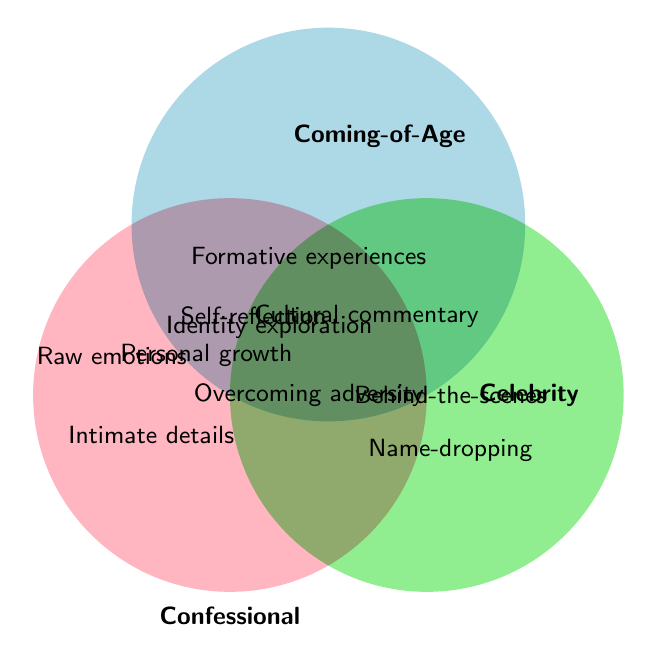What writing styles are unique to the Confessional genre? The Confessional circle does not overlap with other genres for these styles, which appear as standalone elements in the figure.
Answer: Raw emotions, Intimate details What are the shared writing styles between Confessional and Coming-of-Age genres? Identify the overlapping section between the Confessional and Coming-of-Age circles that do not include the Celebrity genre.
Answer: Self-reflection, Personal growth Which style is shared among all three genres? Look in the central overlapping area where Confessional, Coming-of-Age, and Celebrity intersect.
Answer: Overcoming adversity What styles are associated only with the Coming-of-Age genre? These styles are located solely within the Coming-of-Age circle but outside of any overlap with the other circles.
Answer: Formative experiences, Identity exploration Name a writing style that is shared between Coming-of-Age and Celebrity genres but not Confessional. Find the overlapping area between Coming-of-Age and Celebrity circles, excluding the Confessional area.
Answer: Cultural commentary How many unique writing styles are there in total? Count all distinct styles given in the Venn Diagram, ensuring no duplicates.
Answer: 10 Which genre shares the most writing styles with both other genres? Observe and count the number of overlaps with each genre. The Confessional genre overlaps with both the others in multiple sections.
Answer: Confessional How many writing styles are unique to a single genre? Sum the number of styles that do not overlap with any other genre.
Answer: 6 (2 Confessional, 2 Coming-of-Age, 2 Celebrity) Which genres share the style "Behind-the-scenes glimpses"? Identify the section where the style "Behind-the-scenes glimpses" is placed, within the context of the circles.
Answer: Celebrity 